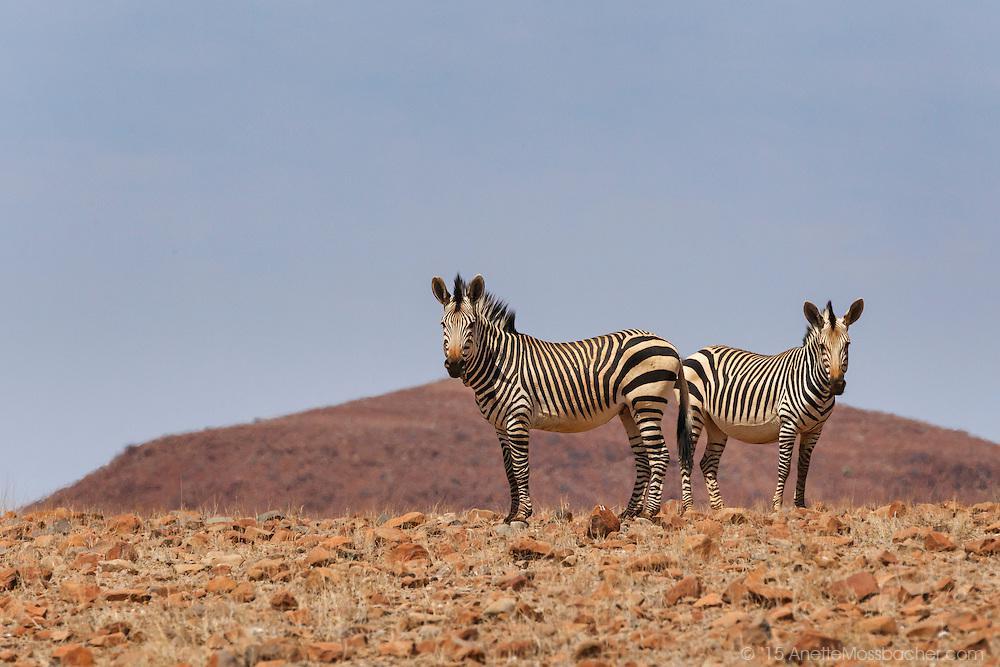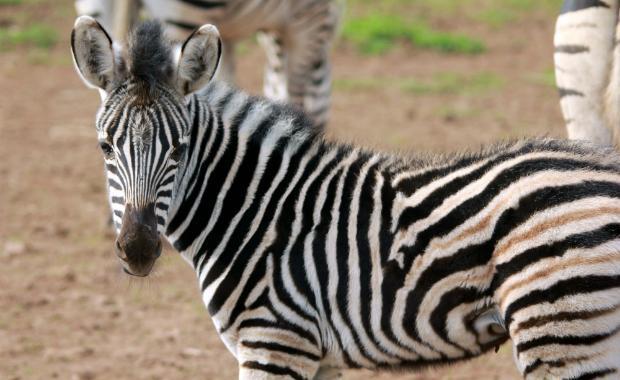The first image is the image on the left, the second image is the image on the right. Given the left and right images, does the statement "There are two zebras and blue sky visible in the left image." hold true? Answer yes or no. Yes. 